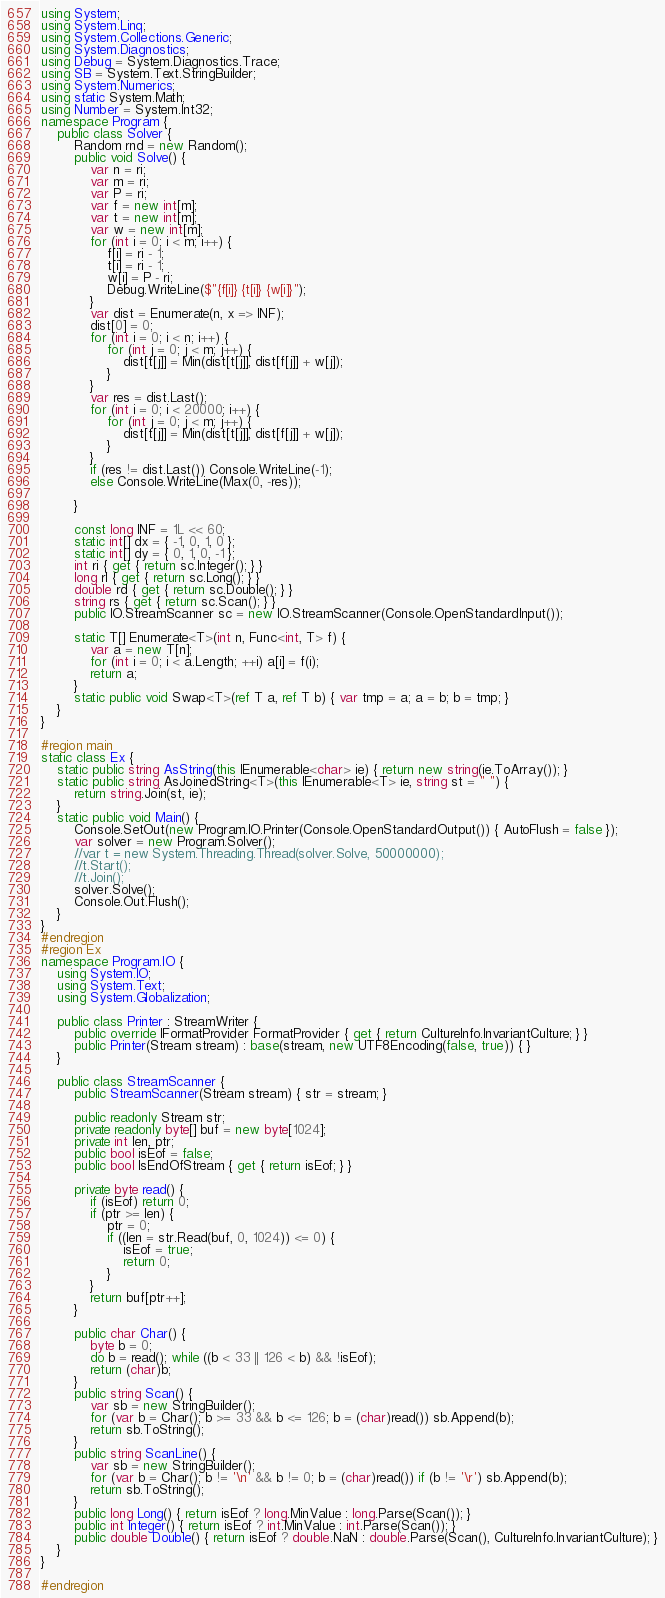<code> <loc_0><loc_0><loc_500><loc_500><_C#_>using System;
using System.Linq;
using System.Collections.Generic;
using System.Diagnostics;
using Debug = System.Diagnostics.Trace;
using SB = System.Text.StringBuilder;
using System.Numerics;
using static System.Math;
using Number = System.Int32;
namespace Program {
	public class Solver {
		Random rnd = new Random();
		public void Solve() {
			var n = ri;
			var m = ri;
			var P = ri;
			var f = new int[m];
			var t = new int[m];
			var w = new int[m];
			for (int i = 0; i < m; i++) {
				f[i] = ri - 1;
				t[i] = ri - 1;
				w[i] = P - ri;
				Debug.WriteLine($"{f[i]} {t[i]} {w[i]}");
			}
			var dist = Enumerate(n, x => INF);
			dist[0] = 0;
			for (int i = 0; i < n; i++) {
				for (int j = 0; j < m; j++) {
					dist[t[j]] = Min(dist[t[j]], dist[f[j]] + w[j]);
				}
			}
			var res = dist.Last();
			for (int i = 0; i < 20000; i++) {
				for (int j = 0; j < m; j++) {
					dist[t[j]] = Min(dist[t[j]], dist[f[j]] + w[j]);
				}
			}
			if (res != dist.Last()) Console.WriteLine(-1);
			else Console.WriteLine(Max(0, -res));

		}

		const long INF = 1L << 60;
		static int[] dx = { -1, 0, 1, 0 };
		static int[] dy = { 0, 1, 0, -1 };
		int ri { get { return sc.Integer(); } }
		long rl { get { return sc.Long(); } }
		double rd { get { return sc.Double(); } }
		string rs { get { return sc.Scan(); } }
		public IO.StreamScanner sc = new IO.StreamScanner(Console.OpenStandardInput());

		static T[] Enumerate<T>(int n, Func<int, T> f) {
			var a = new T[n];
			for (int i = 0; i < a.Length; ++i) a[i] = f(i);
			return a;
		}
		static public void Swap<T>(ref T a, ref T b) { var tmp = a; a = b; b = tmp; }
	}
}

#region main
static class Ex {
	static public string AsString(this IEnumerable<char> ie) { return new string(ie.ToArray()); }
	static public string AsJoinedString<T>(this IEnumerable<T> ie, string st = " ") {
		return string.Join(st, ie);
	}
	static public void Main() {
		Console.SetOut(new Program.IO.Printer(Console.OpenStandardOutput()) { AutoFlush = false });
		var solver = new Program.Solver();
		//var t = new System.Threading.Thread(solver.Solve, 50000000);
		//t.Start();
		//t.Join();
		solver.Solve();
		Console.Out.Flush();
	}
}
#endregion
#region Ex
namespace Program.IO {
	using System.IO;
	using System.Text;
	using System.Globalization;

	public class Printer : StreamWriter {
		public override IFormatProvider FormatProvider { get { return CultureInfo.InvariantCulture; } }
		public Printer(Stream stream) : base(stream, new UTF8Encoding(false, true)) { }
	}

	public class StreamScanner {
		public StreamScanner(Stream stream) { str = stream; }

		public readonly Stream str;
		private readonly byte[] buf = new byte[1024];
		private int len, ptr;
		public bool isEof = false;
		public bool IsEndOfStream { get { return isEof; } }

		private byte read() {
			if (isEof) return 0;
			if (ptr >= len) {
				ptr = 0;
				if ((len = str.Read(buf, 0, 1024)) <= 0) {
					isEof = true;
					return 0;
				}
			}
			return buf[ptr++];
		}

		public char Char() {
			byte b = 0;
			do b = read(); while ((b < 33 || 126 < b) && !isEof);
			return (char)b;
		}
		public string Scan() {
			var sb = new StringBuilder();
			for (var b = Char(); b >= 33 && b <= 126; b = (char)read()) sb.Append(b);
			return sb.ToString();
		}
		public string ScanLine() {
			var sb = new StringBuilder();
			for (var b = Char(); b != '\n' && b != 0; b = (char)read()) if (b != '\r') sb.Append(b);
			return sb.ToString();
		}
		public long Long() { return isEof ? long.MinValue : long.Parse(Scan()); }
		public int Integer() { return isEof ? int.MinValue : int.Parse(Scan()); }
		public double Double() { return isEof ? double.NaN : double.Parse(Scan(), CultureInfo.InvariantCulture); }
	}
}

#endregion
</code> 